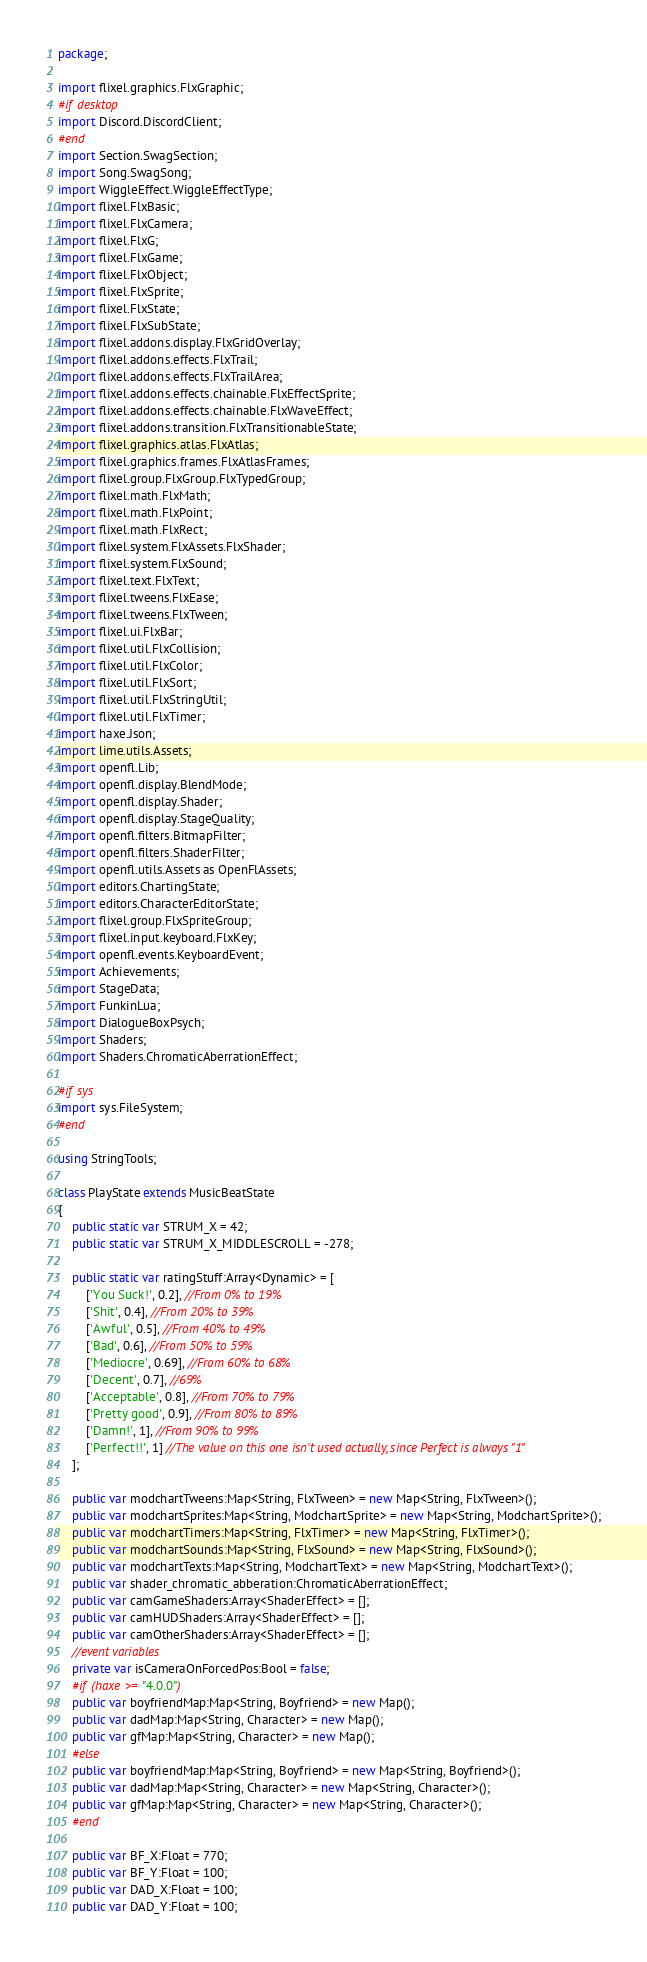<code> <loc_0><loc_0><loc_500><loc_500><_Haxe_>package;

import flixel.graphics.FlxGraphic;
#if desktop
import Discord.DiscordClient;
#end
import Section.SwagSection;
import Song.SwagSong;
import WiggleEffect.WiggleEffectType;
import flixel.FlxBasic;
import flixel.FlxCamera;
import flixel.FlxG;
import flixel.FlxGame;
import flixel.FlxObject;
import flixel.FlxSprite;
import flixel.FlxState;
import flixel.FlxSubState;
import flixel.addons.display.FlxGridOverlay;
import flixel.addons.effects.FlxTrail;
import flixel.addons.effects.FlxTrailArea;
import flixel.addons.effects.chainable.FlxEffectSprite;
import flixel.addons.effects.chainable.FlxWaveEffect;
import flixel.addons.transition.FlxTransitionableState;
import flixel.graphics.atlas.FlxAtlas;
import flixel.graphics.frames.FlxAtlasFrames;
import flixel.group.FlxGroup.FlxTypedGroup;
import flixel.math.FlxMath;
import flixel.math.FlxPoint;
import flixel.math.FlxRect;
import flixel.system.FlxAssets.FlxShader;
import flixel.system.FlxSound;
import flixel.text.FlxText;
import flixel.tweens.FlxEase;
import flixel.tweens.FlxTween;
import flixel.ui.FlxBar;
import flixel.util.FlxCollision;
import flixel.util.FlxColor;
import flixel.util.FlxSort;
import flixel.util.FlxStringUtil;
import flixel.util.FlxTimer;
import haxe.Json;
import lime.utils.Assets;
import openfl.Lib;
import openfl.display.BlendMode;
import openfl.display.Shader;
import openfl.display.StageQuality;
import openfl.filters.BitmapFilter;
import openfl.filters.ShaderFilter;
import openfl.utils.Assets as OpenFlAssets;
import editors.ChartingState;
import editors.CharacterEditorState;
import flixel.group.FlxSpriteGroup;
import flixel.input.keyboard.FlxKey;
import openfl.events.KeyboardEvent;
import Achievements;
import StageData;
import FunkinLua;
import DialogueBoxPsych;
import Shaders;
import Shaders.ChromaticAberrationEffect;

#if sys
import sys.FileSystem;
#end

using StringTools;

class PlayState extends MusicBeatState
{
	public static var STRUM_X = 42;
	public static var STRUM_X_MIDDLESCROLL = -278;

	public static var ratingStuff:Array<Dynamic> = [
		['You Suck!', 0.2], //From 0% to 19%
		['Shit', 0.4], //From 20% to 39%
		['Awful', 0.5], //From 40% to 49%
		['Bad', 0.6], //From 50% to 59%
		['Mediocre', 0.69], //From 60% to 68%
		['Decent', 0.7], //69%
		['Acceptable', 0.8], //From 70% to 79%
		['Pretty good', 0.9], //From 80% to 89%
		['Damn!', 1], //From 90% to 99%
		['Perfect!!', 1] //The value on this one isn't used actually, since Perfect is always "1"
	];
	
	public var modchartTweens:Map<String, FlxTween> = new Map<String, FlxTween>();
	public var modchartSprites:Map<String, ModchartSprite> = new Map<String, ModchartSprite>();
	public var modchartTimers:Map<String, FlxTimer> = new Map<String, FlxTimer>();
	public var modchartSounds:Map<String, FlxSound> = new Map<String, FlxSound>();
	public var modchartTexts:Map<String, ModchartText> = new Map<String, ModchartText>();
	public var shader_chromatic_abberation:ChromaticAberrationEffect;
	public var camGameShaders:Array<ShaderEffect> = [];
	public var camHUDShaders:Array<ShaderEffect> = [];
	public var camOtherShaders:Array<ShaderEffect> = [];
	//event variables
	private var isCameraOnForcedPos:Bool = false;
	#if (haxe >= "4.0.0")
	public var boyfriendMap:Map<String, Boyfriend> = new Map();
	public var dadMap:Map<String, Character> = new Map();
	public var gfMap:Map<String, Character> = new Map();
	#else
	public var boyfriendMap:Map<String, Boyfriend> = new Map<String, Boyfriend>();
	public var dadMap:Map<String, Character> = new Map<String, Character>();
	public var gfMap:Map<String, Character> = new Map<String, Character>();
	#end

	public var BF_X:Float = 770;
	public var BF_Y:Float = 100;
	public var DAD_X:Float = 100;
	public var DAD_Y:Float = 100;</code> 